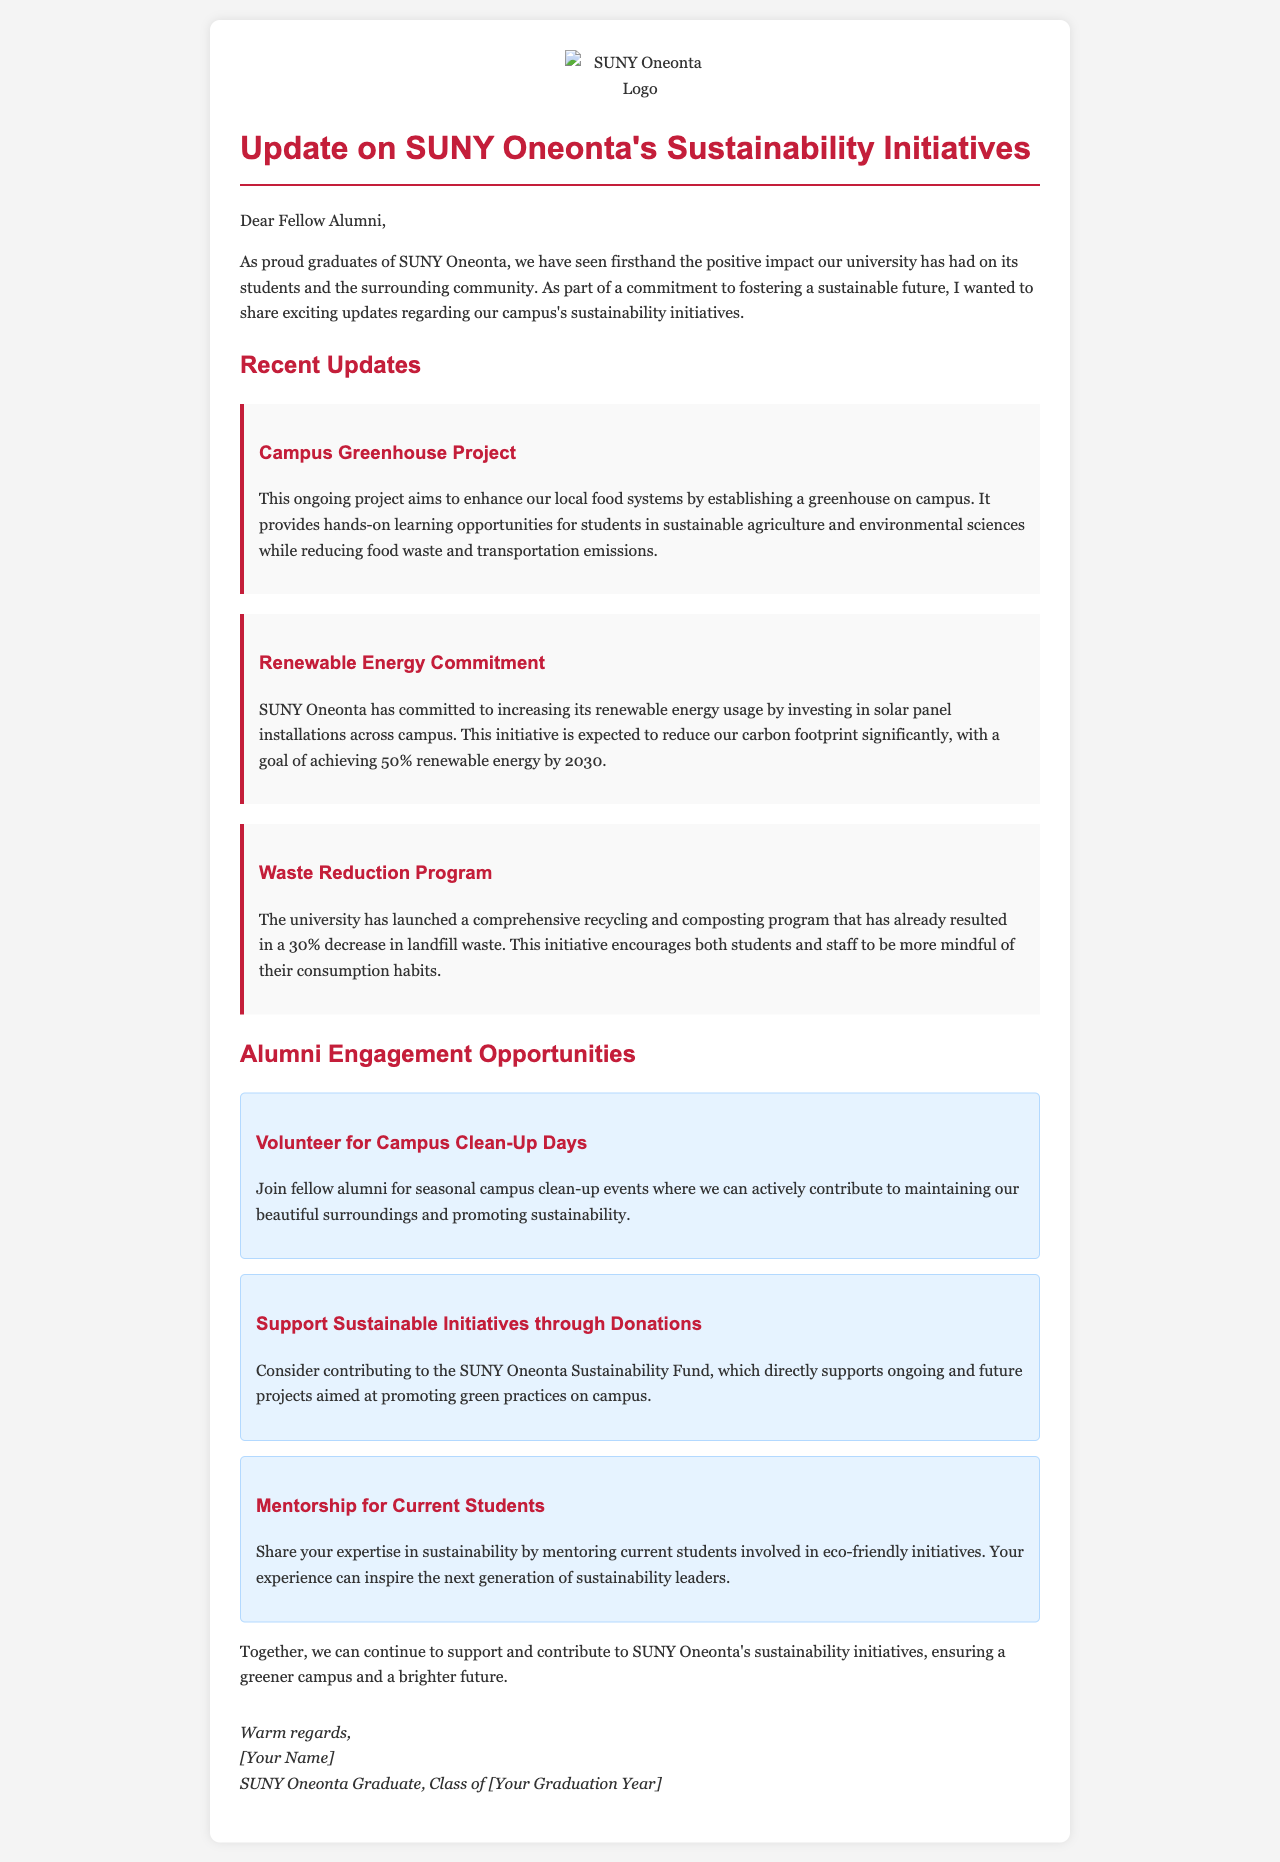What is the title of the update? The title of the update as stated in the document header is "Update on SUNY Oneonta's Sustainability Initiatives."
Answer: Update on SUNY Oneonta's Sustainability Initiatives What is the goal for renewable energy by 2030? The document specifies that the goal is to achieve 50% renewable energy usage by 2030.
Answer: 50% What project focuses on enhancing local food systems? The project mentioned in the update that aims to enhance local food systems is the "Campus Greenhouse Project."
Answer: Campus Greenhouse Project What percentage decrease in landfill waste has the Waste Reduction Program achieved? According to the document, the Waste Reduction Program has resulted in a 30% decrease in landfill waste.
Answer: 30% How can alumni support sustainable initiatives financially? The document suggests that alumni can support sustainable initiatives by contributing to the "SUNY Oneonta Sustainability Fund."
Answer: SUNY Oneonta Sustainability Fund What opportunity involves mentoring? The document mentions "Mentorship for Current Students" as an opportunity where alumni can share their expertise.
Answer: Mentorship for Current Students What are alumni encouraged to do at campus clean-up events? Alumni are encouraged to participate in "seasonal campus clean-up events."
Answer: seasonal campus clean-up events What color is used for headings in the document? The document indicates that headings are colored with the code #c41e3a, which is a shade of red.
Answer: #c41e3a 